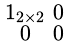<formula> <loc_0><loc_0><loc_500><loc_500>\begin{smallmatrix} 1 _ { 2 \times 2 } & 0 \\ 0 & 0 \end{smallmatrix}</formula> 